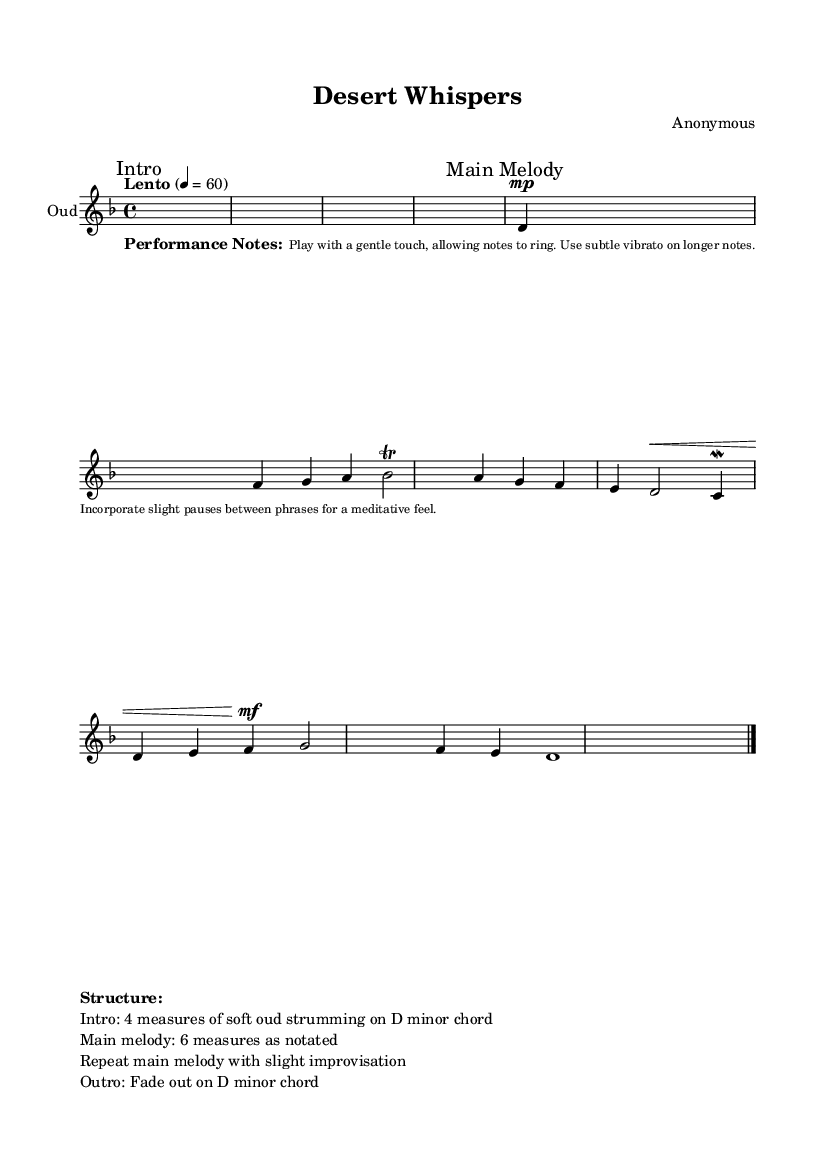What is the key signature of this music? The key signature can be found at the beginning of the staff. In this case, it is D minor, which is indicated by one flat (B flat) in the key signature.
Answer: D minor What is the time signature of this music? The time signature is found next to the key signature at the beginning of the piece. Here, it is 4/4, indicating four beats per measure.
Answer: 4/4 What is the tempo marking for this piece? The tempo marking is indicated at the beginning of the score. In this piece, it is marked as "Lento," which means slow.
Answer: Lento How many measures are in the Main Melody section? The Main Melody section is defined in the markup above the music. It states that the Main Melody consists of 6 measures.
Answer: 6 measures What dynamic marking indicates the main expression level in the melody? The dynamic marking can be found before certain notes in the music. In this case, the marking "mf" indicates a mezzo forte, which means moderately loud.
Answer: mf Which performance technique is suggested for long notes? The performance notes label an instruction for long notes under the lyrics. Specifically, it mentions using "subtle vibrato" on longer notes to enhance the expressiveness of the performance.
Answer: Subtle vibrato What chord does the piece fade out on in the Outro? At the end of the structure, the music notes and the performance notes indicate that the piece fades out on a D minor chord, serving as both the closing and tonal center of the piece.
Answer: D minor chord 